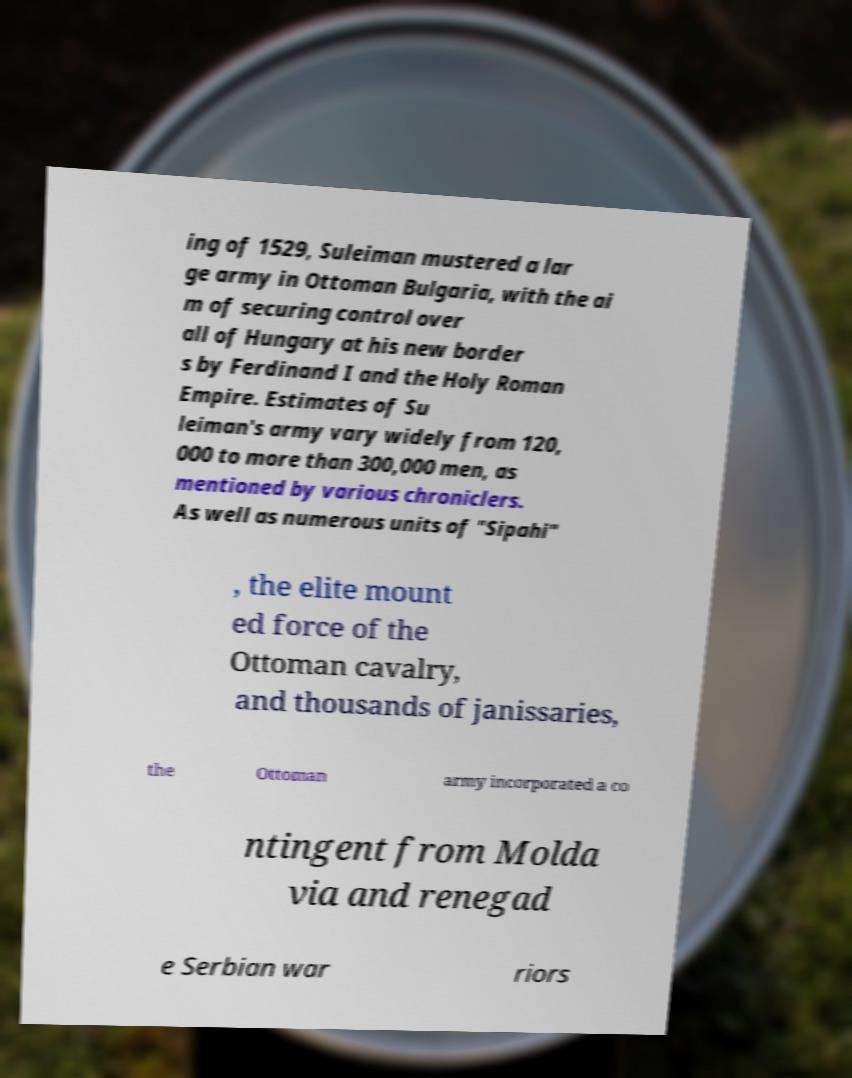What messages or text are displayed in this image? I need them in a readable, typed format. ing of 1529, Suleiman mustered a lar ge army in Ottoman Bulgaria, with the ai m of securing control over all of Hungary at his new border s by Ferdinand I and the Holy Roman Empire. Estimates of Su leiman's army vary widely from 120, 000 to more than 300,000 men, as mentioned by various chroniclers. As well as numerous units of "Sipahi" , the elite mount ed force of the Ottoman cavalry, and thousands of janissaries, the Ottoman army incorporated a co ntingent from Molda via and renegad e Serbian war riors 